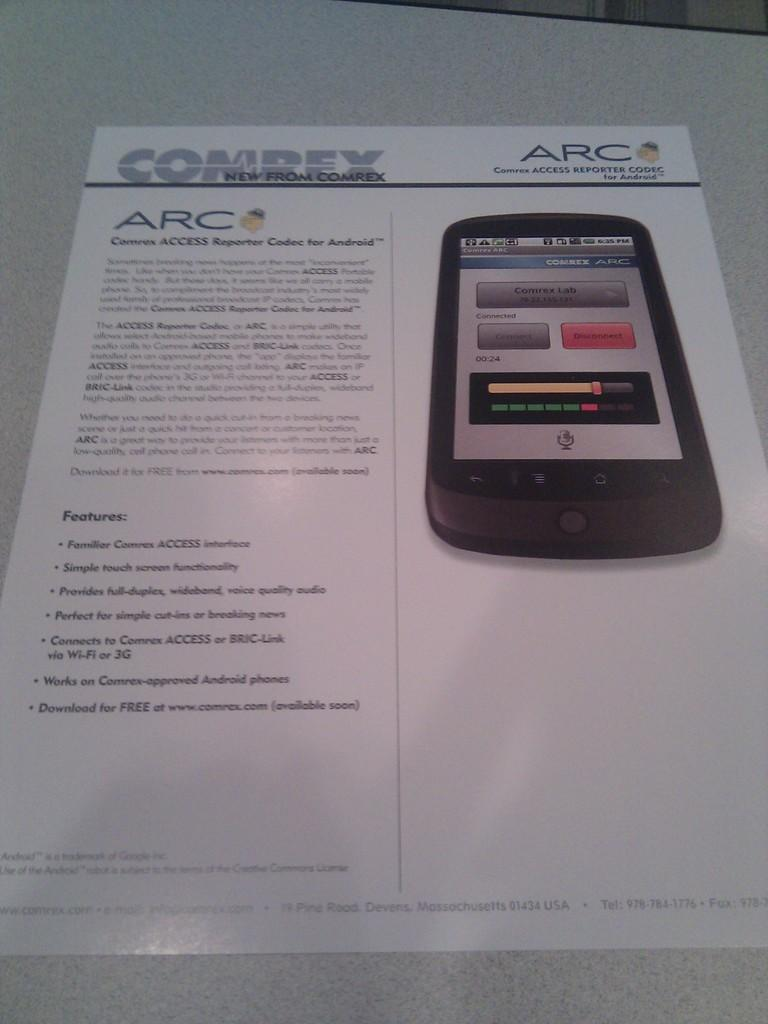<image>
Offer a succinct explanation of the picture presented. A Comrex brochure with a picture of a cell phone. 